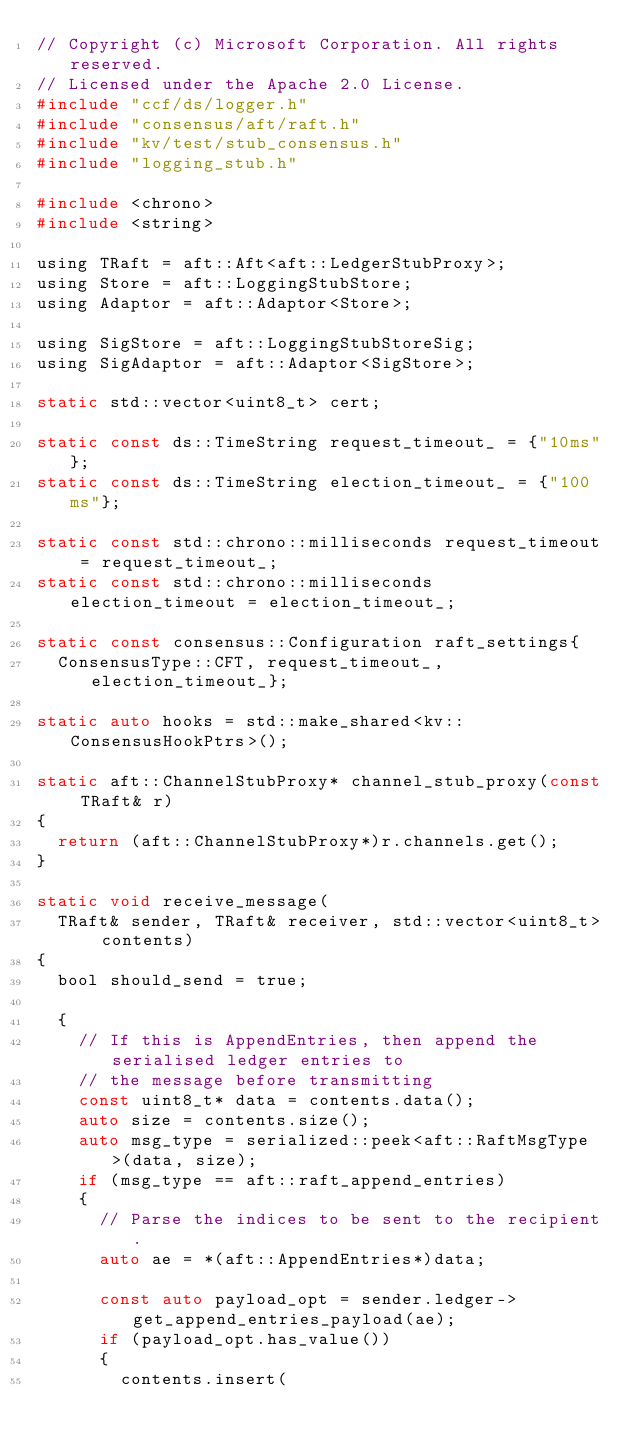Convert code to text. <code><loc_0><loc_0><loc_500><loc_500><_C_>// Copyright (c) Microsoft Corporation. All rights reserved.
// Licensed under the Apache 2.0 License.
#include "ccf/ds/logger.h"
#include "consensus/aft/raft.h"
#include "kv/test/stub_consensus.h"
#include "logging_stub.h"

#include <chrono>
#include <string>

using TRaft = aft::Aft<aft::LedgerStubProxy>;
using Store = aft::LoggingStubStore;
using Adaptor = aft::Adaptor<Store>;

using SigStore = aft::LoggingStubStoreSig;
using SigAdaptor = aft::Adaptor<SigStore>;

static std::vector<uint8_t> cert;

static const ds::TimeString request_timeout_ = {"10ms"};
static const ds::TimeString election_timeout_ = {"100ms"};

static const std::chrono::milliseconds request_timeout = request_timeout_;
static const std::chrono::milliseconds election_timeout = election_timeout_;

static const consensus::Configuration raft_settings{
  ConsensusType::CFT, request_timeout_, election_timeout_};

static auto hooks = std::make_shared<kv::ConsensusHookPtrs>();

static aft::ChannelStubProxy* channel_stub_proxy(const TRaft& r)
{
  return (aft::ChannelStubProxy*)r.channels.get();
}

static void receive_message(
  TRaft& sender, TRaft& receiver, std::vector<uint8_t> contents)
{
  bool should_send = true;

  {
    // If this is AppendEntries, then append the serialised ledger entries to
    // the message before transmitting
    const uint8_t* data = contents.data();
    auto size = contents.size();
    auto msg_type = serialized::peek<aft::RaftMsgType>(data, size);
    if (msg_type == aft::raft_append_entries)
    {
      // Parse the indices to be sent to the recipient.
      auto ae = *(aft::AppendEntries*)data;

      const auto payload_opt = sender.ledger->get_append_entries_payload(ae);
      if (payload_opt.has_value())
      {
        contents.insert(</code> 